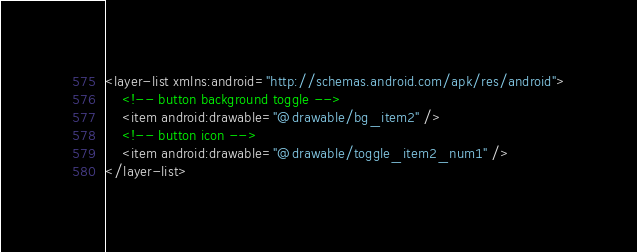Convert code to text. <code><loc_0><loc_0><loc_500><loc_500><_XML_><layer-list xmlns:android="http://schemas.android.com/apk/res/android">
    <!-- button background toggle -->
    <item android:drawable="@drawable/bg_item2" />
    <!-- button icon -->
    <item android:drawable="@drawable/toggle_item2_num1" />
</layer-list></code> 